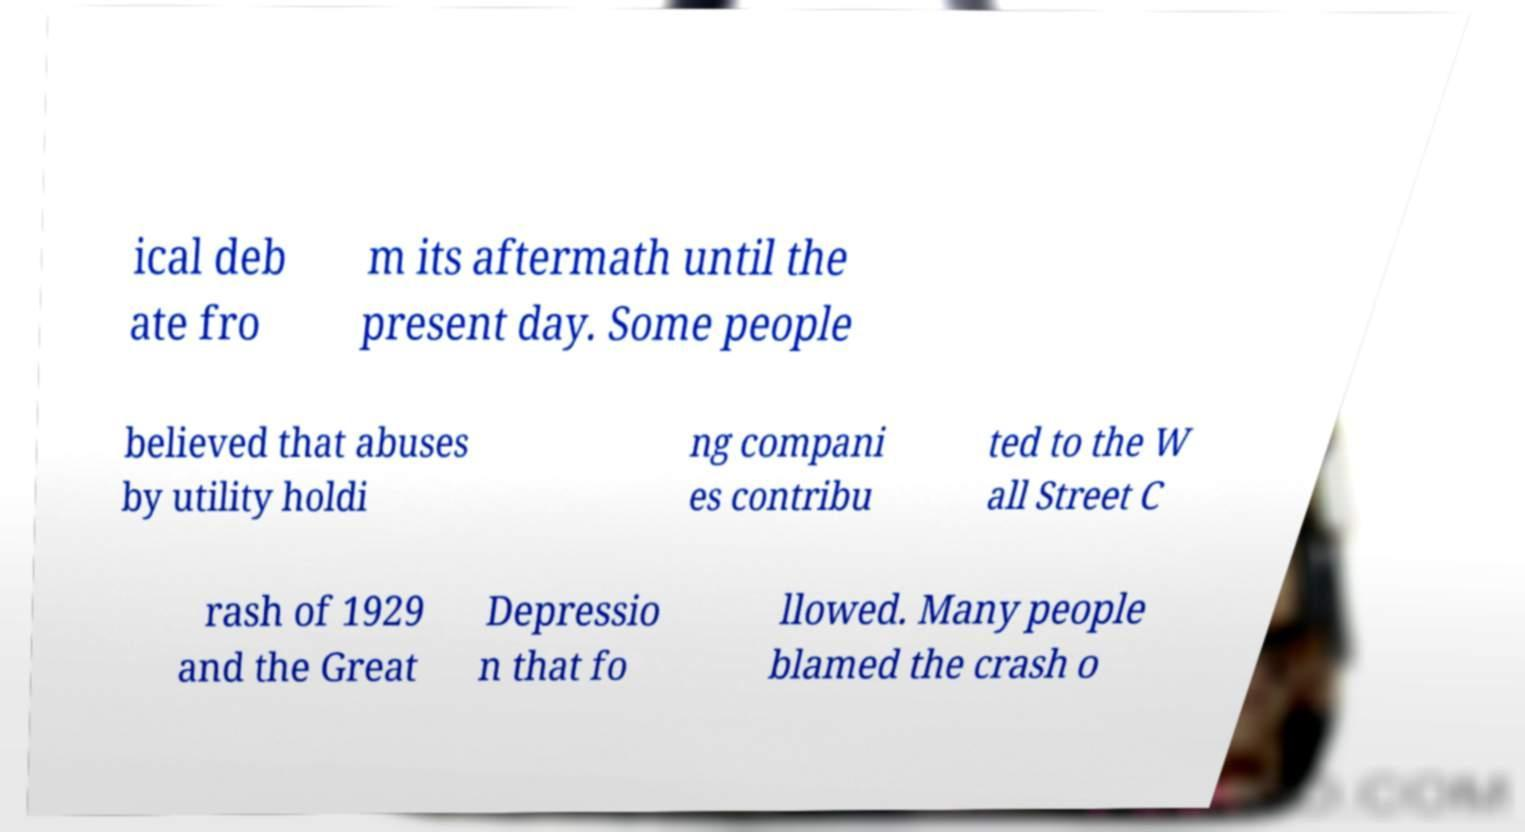I need the written content from this picture converted into text. Can you do that? ical deb ate fro m its aftermath until the present day. Some people believed that abuses by utility holdi ng compani es contribu ted to the W all Street C rash of 1929 and the Great Depressio n that fo llowed. Many people blamed the crash o 